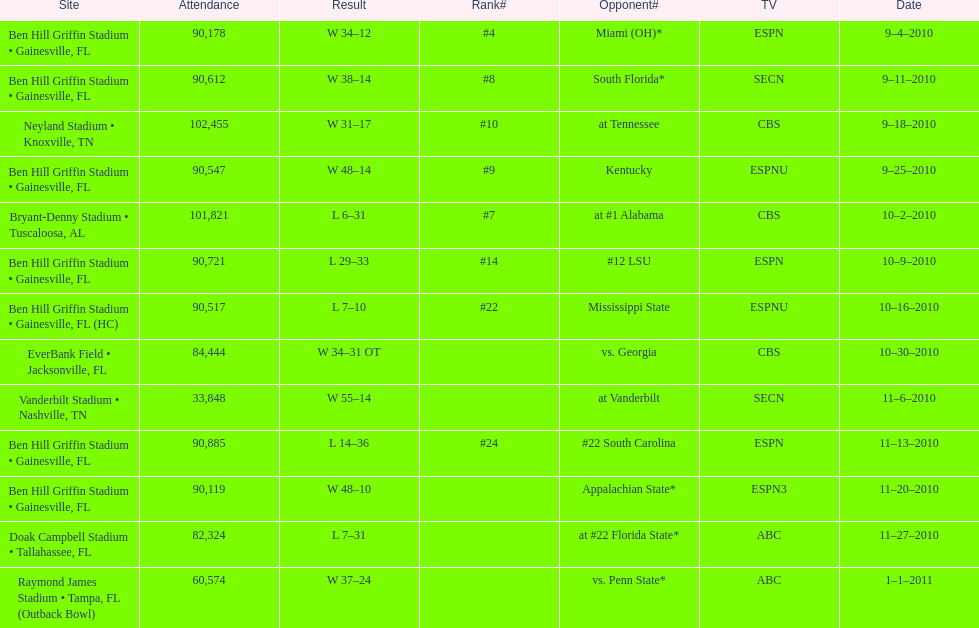How many games were played at the ben hill griffin stadium during the 2010-2011 season? 7. 